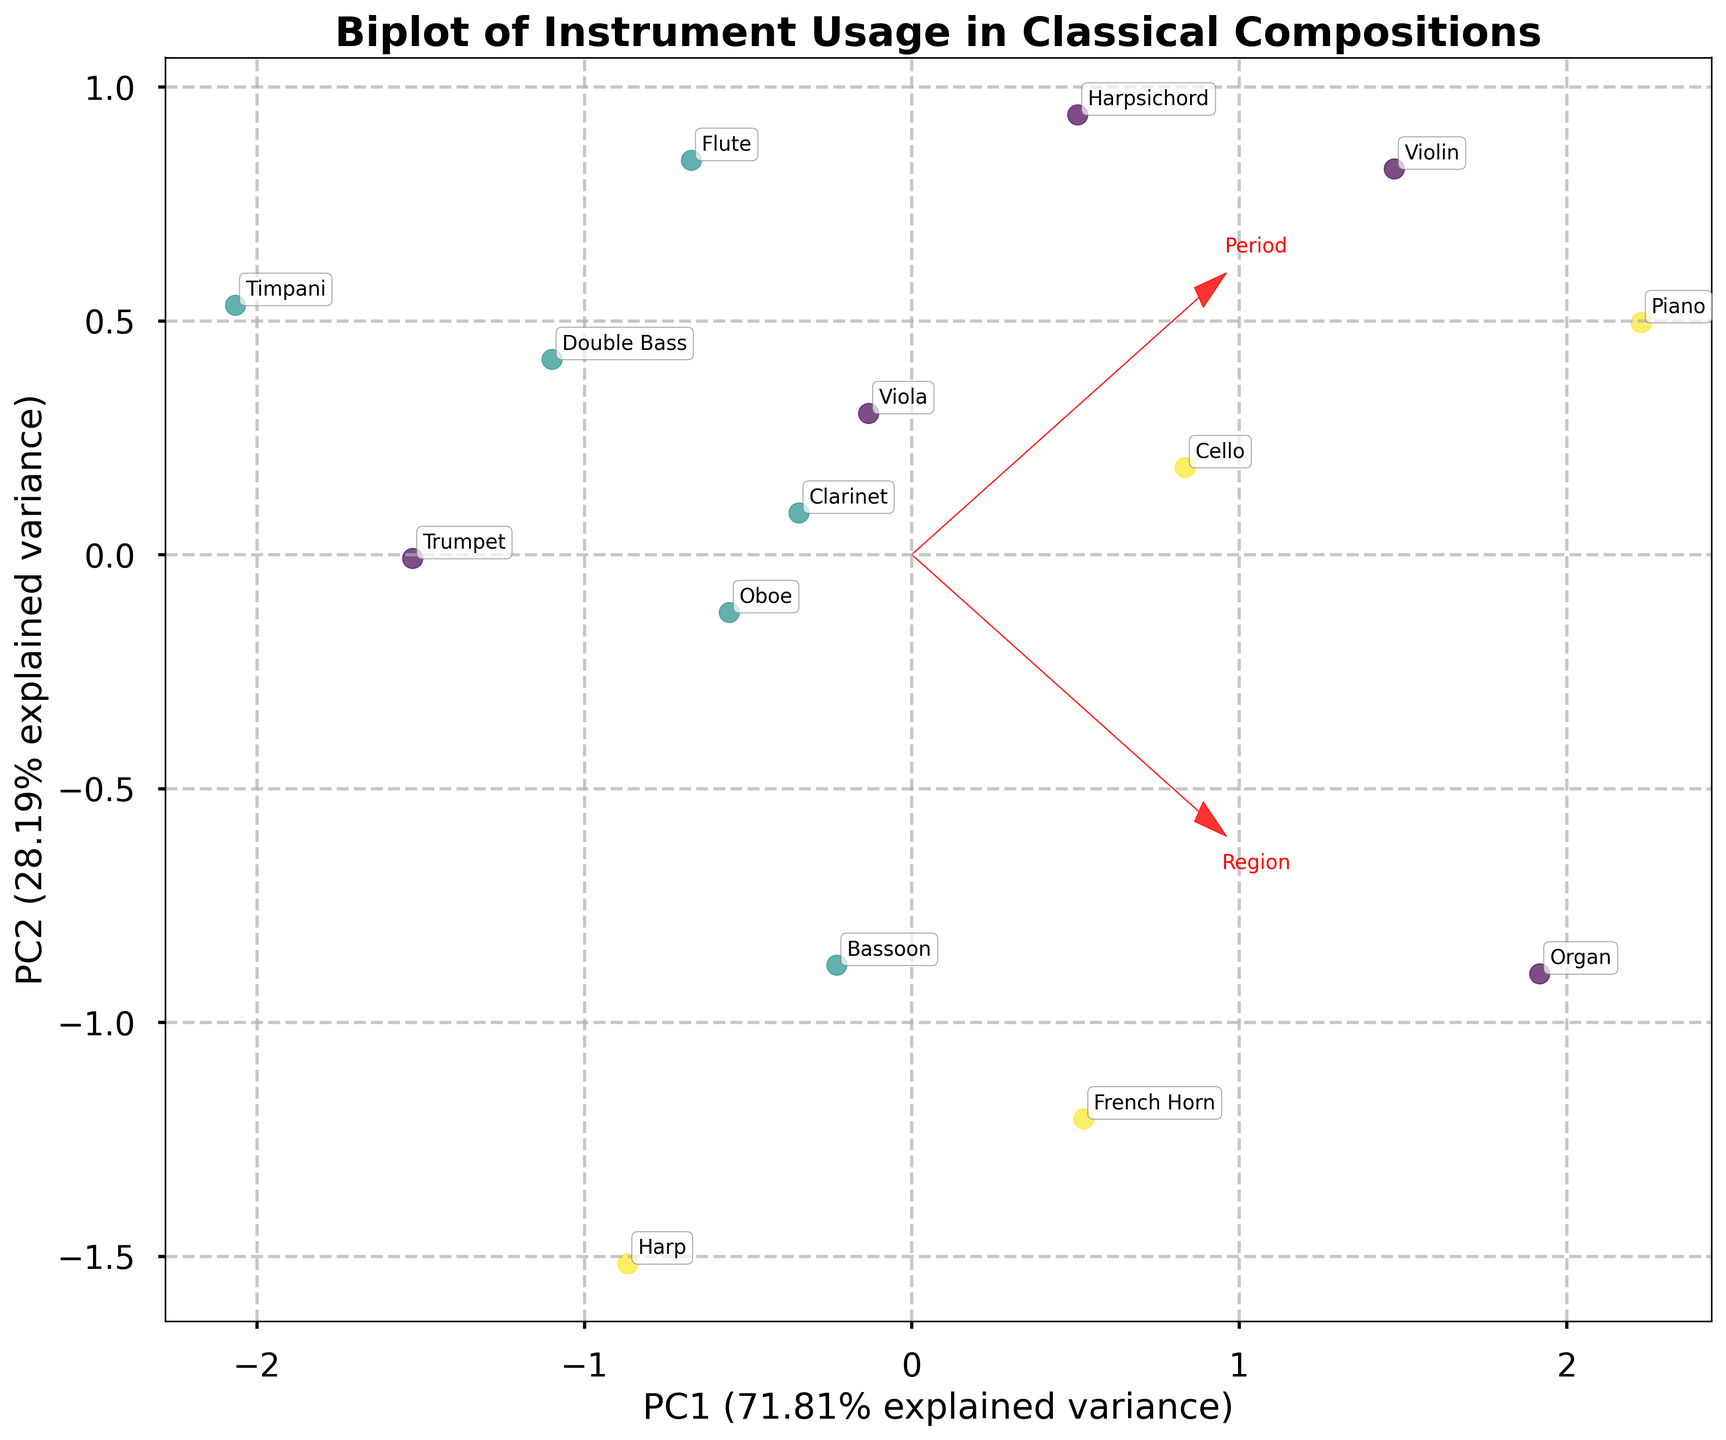How many instruments fall into each period as shown by the biplot? Examine the color-coded legend to identify unique colors representing each period. Count the instruments plotted against each color.
Answer: Baroque: 5, Classical: 5, Romantic: 5 Which instrument has the highest frequency and which period does it belong to? Locate the instruments on the biplot, identify the one farthest right along the "Frequency" axis. Check the annotation and refer to the color legend.
Answer: Piano, Romantic What's the range of complexity scores for instruments in the Classical period? Note the y-axis positions of instruments coded with the color representing the Classical period. Identify the highest and lowest values, then calculate the range.
Answer: 0.3 Which instrument from the Romantic period has the highest complexity score? Find instruments in Romantic period using the color code, observe the vertical position on the biplot and identify the highest point.
Answer: Piano Are there more instruments with high frequency in the Baroque or Classical period? Analyze the horizontal positions of instruments in each period. Compare the number of points further right in Baroque and Classical periods.
Answer: Baroque Between the violin and the clarinet, which has a higher complexity score? Locate the annotations for violin and clarinet on the biplot. Compare their vertical positions along the "Complexity" axis.
Answer: Bassoon Which period shows a higher spread in instrument complexity? Review the instrument positions along the vertical axis for each period. Assess the spread by observing the range and distribution.
Answer: Classical How do the loads of "Frequency" and "Complexity" appear in the biplot? Look for the red arrows representing loadings vectors. Identify their direction and magnitude from the origin.
Answer: Both are diagonal with different lengths What is the instrument located closest to the origin of the PCA plot? Identify the instrument positioned nearest to the intersection of the x and y axes (where values are zero).
Answer: Timpani Which region has the most instruments with high complexity scores? Observe the vertical positions of instruments, noting their complexity. Refer to the annotation and count complexity scores for each region.
Answer: Germany 